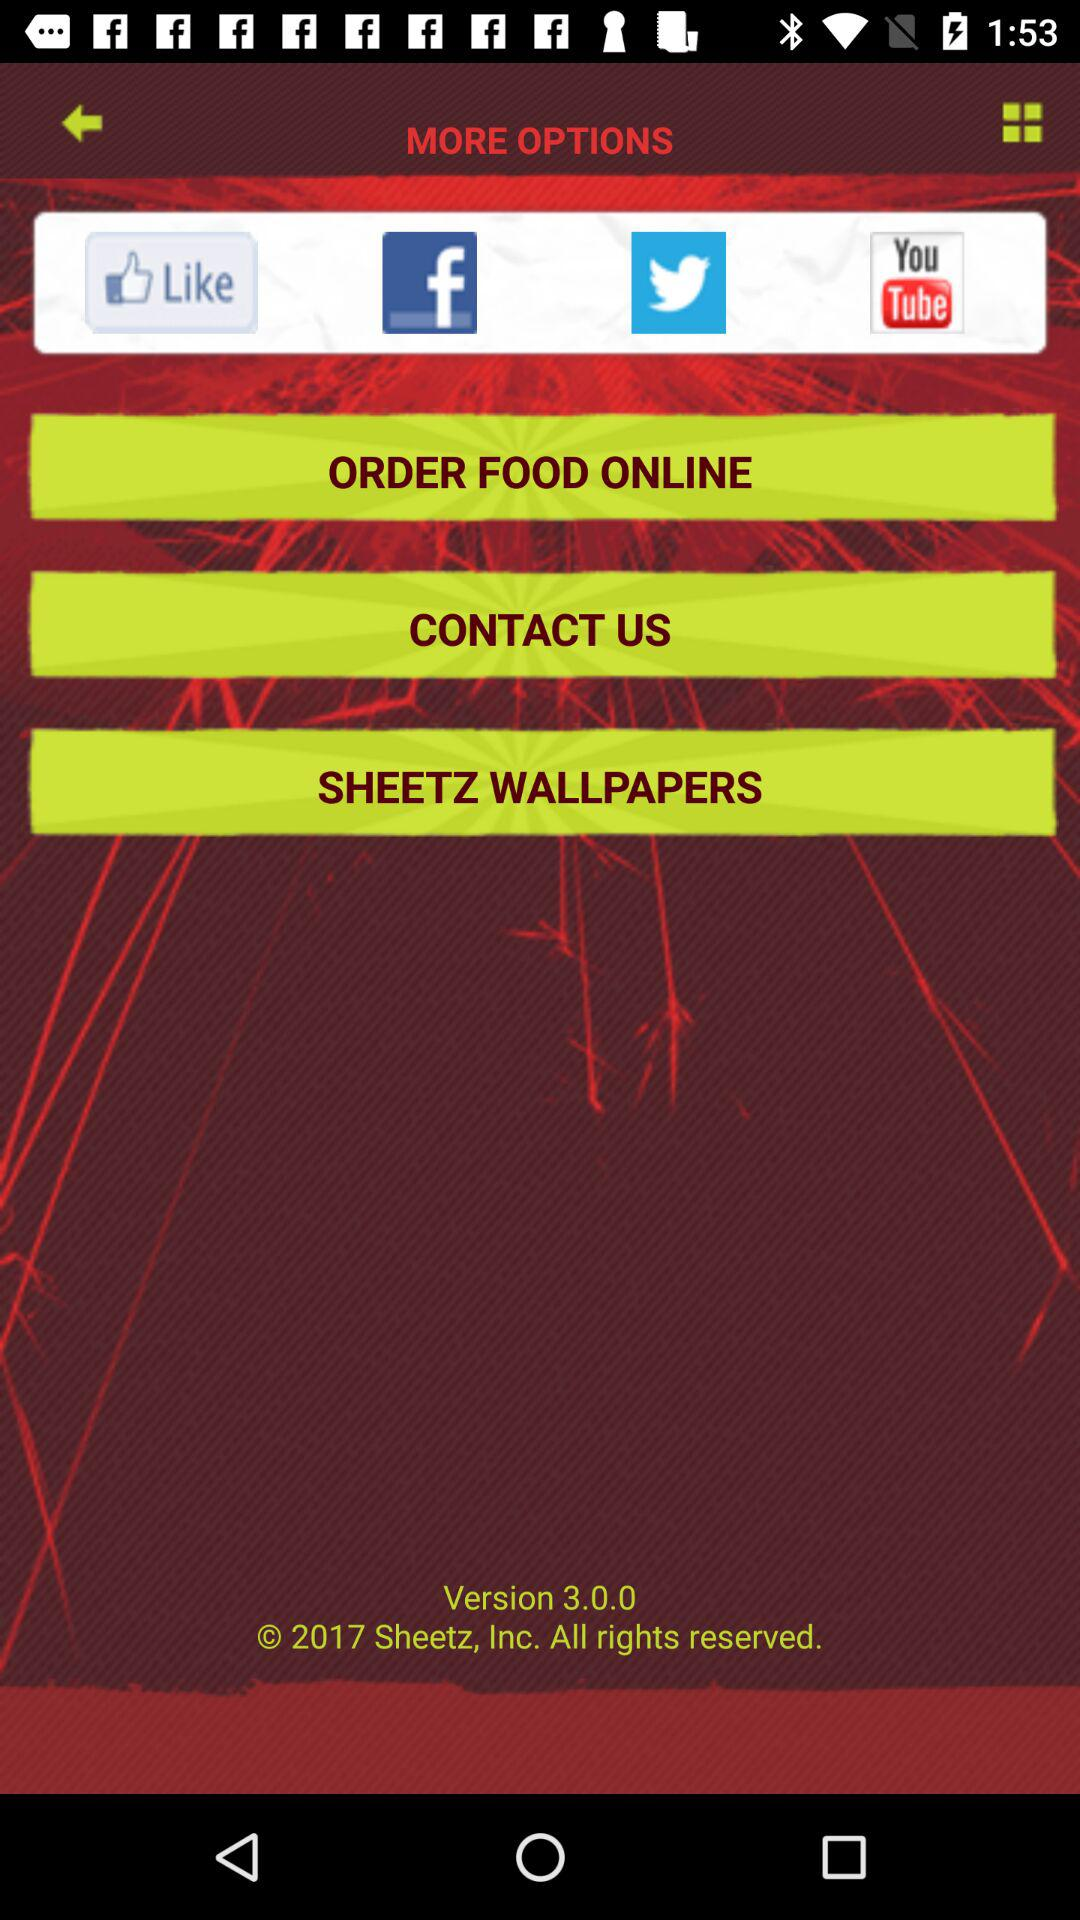Which version is used? The used version is 3.0.0. 